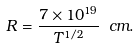Convert formula to latex. <formula><loc_0><loc_0><loc_500><loc_500>R = \frac { 7 \times 1 0 ^ { 1 9 } } { T ^ { 1 / 2 } } \ c m .</formula> 